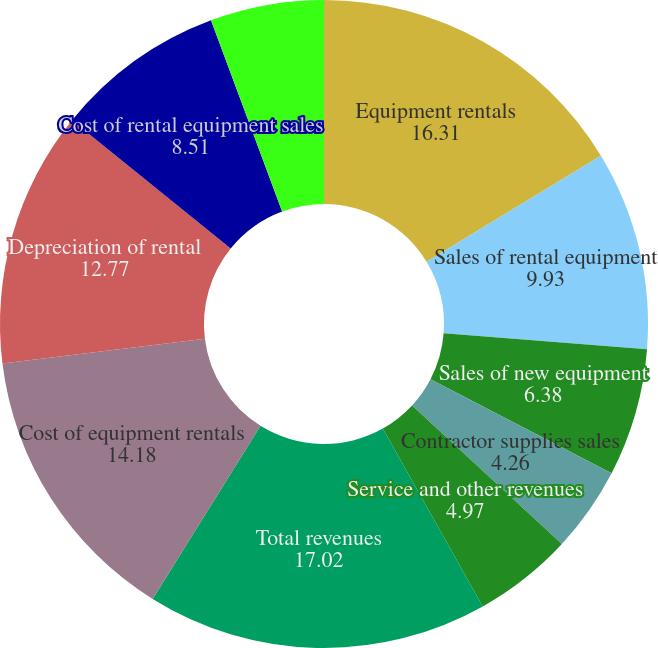<chart> <loc_0><loc_0><loc_500><loc_500><pie_chart><fcel>Equipment rentals<fcel>Sales of rental equipment<fcel>Sales of new equipment<fcel>Contractor supplies sales<fcel>Service and other revenues<fcel>Total revenues<fcel>Cost of equipment rentals<fcel>Depreciation of rental<fcel>Cost of rental equipment sales<fcel>Cost of new equipment sales<nl><fcel>16.31%<fcel>9.93%<fcel>6.38%<fcel>4.26%<fcel>4.97%<fcel>17.02%<fcel>14.18%<fcel>12.77%<fcel>8.51%<fcel>5.67%<nl></chart> 